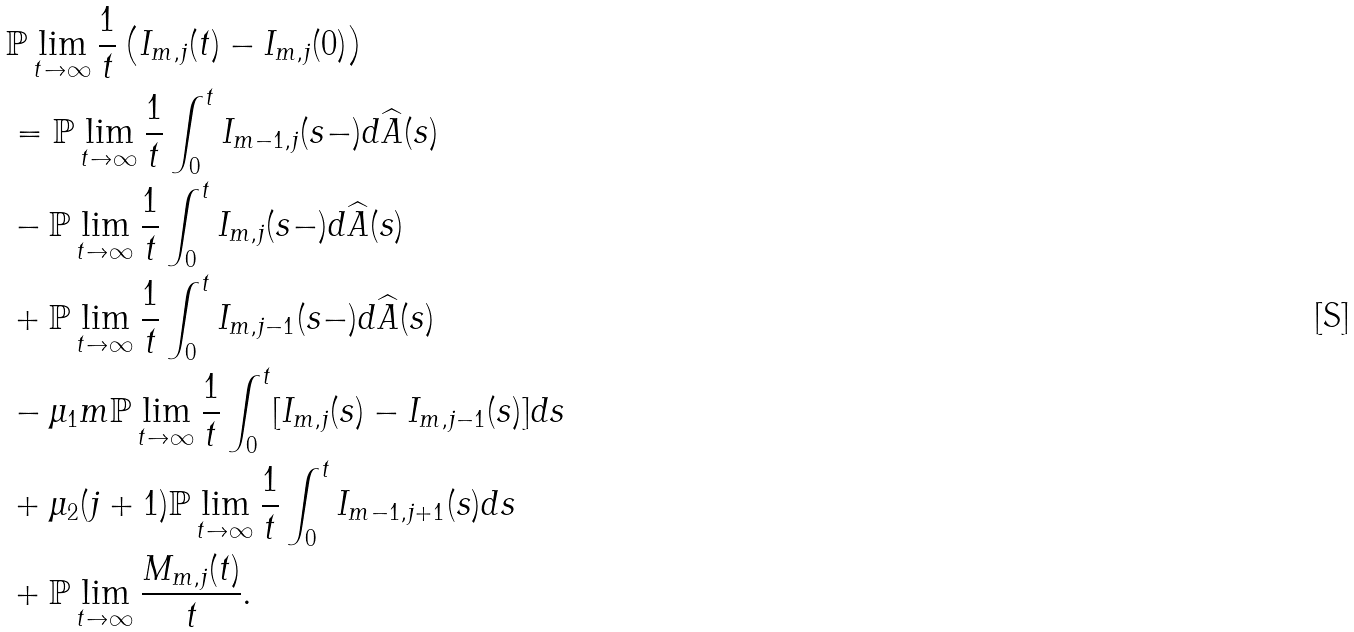<formula> <loc_0><loc_0><loc_500><loc_500>& \mathbb { P } \lim _ { t \to \infty } \frac { 1 } { t } \left ( I _ { m , j } ( t ) - I _ { m , j } ( 0 ) \right ) \\ & = \mathbb { P } \lim _ { t \to \infty } \frac { 1 } { t } \int _ { 0 } ^ { t } I _ { m - 1 , j } ( s - ) d \widehat { A } ( s ) \\ & - \mathbb { P } \lim _ { t \to \infty } \frac { 1 } { t } \int _ { 0 } ^ { t } I _ { m , j } ( s - ) d \widehat { A } ( s ) \\ & + \mathbb { P } \lim _ { t \to \infty } \frac { 1 } { t } \int _ { 0 } ^ { t } I _ { m , j - 1 } ( s - ) d \widehat { A } ( s ) \\ & - \mu _ { 1 } m \mathbb { P } \lim _ { t \to \infty } \frac { 1 } { t } \int _ { 0 } ^ { t } [ I _ { m , j } ( s ) - I _ { m , j - 1 } ( s ) ] d s \\ & + \mu _ { 2 } ( j + 1 ) \mathbb { P } \lim _ { t \to \infty } \frac { 1 } { t } \int _ { 0 } ^ { t } I _ { m - 1 , j + 1 } ( s ) d s \\ & + \mathbb { P } \lim _ { t \to \infty } \frac { M _ { m , j } ( t ) } { t } .</formula> 